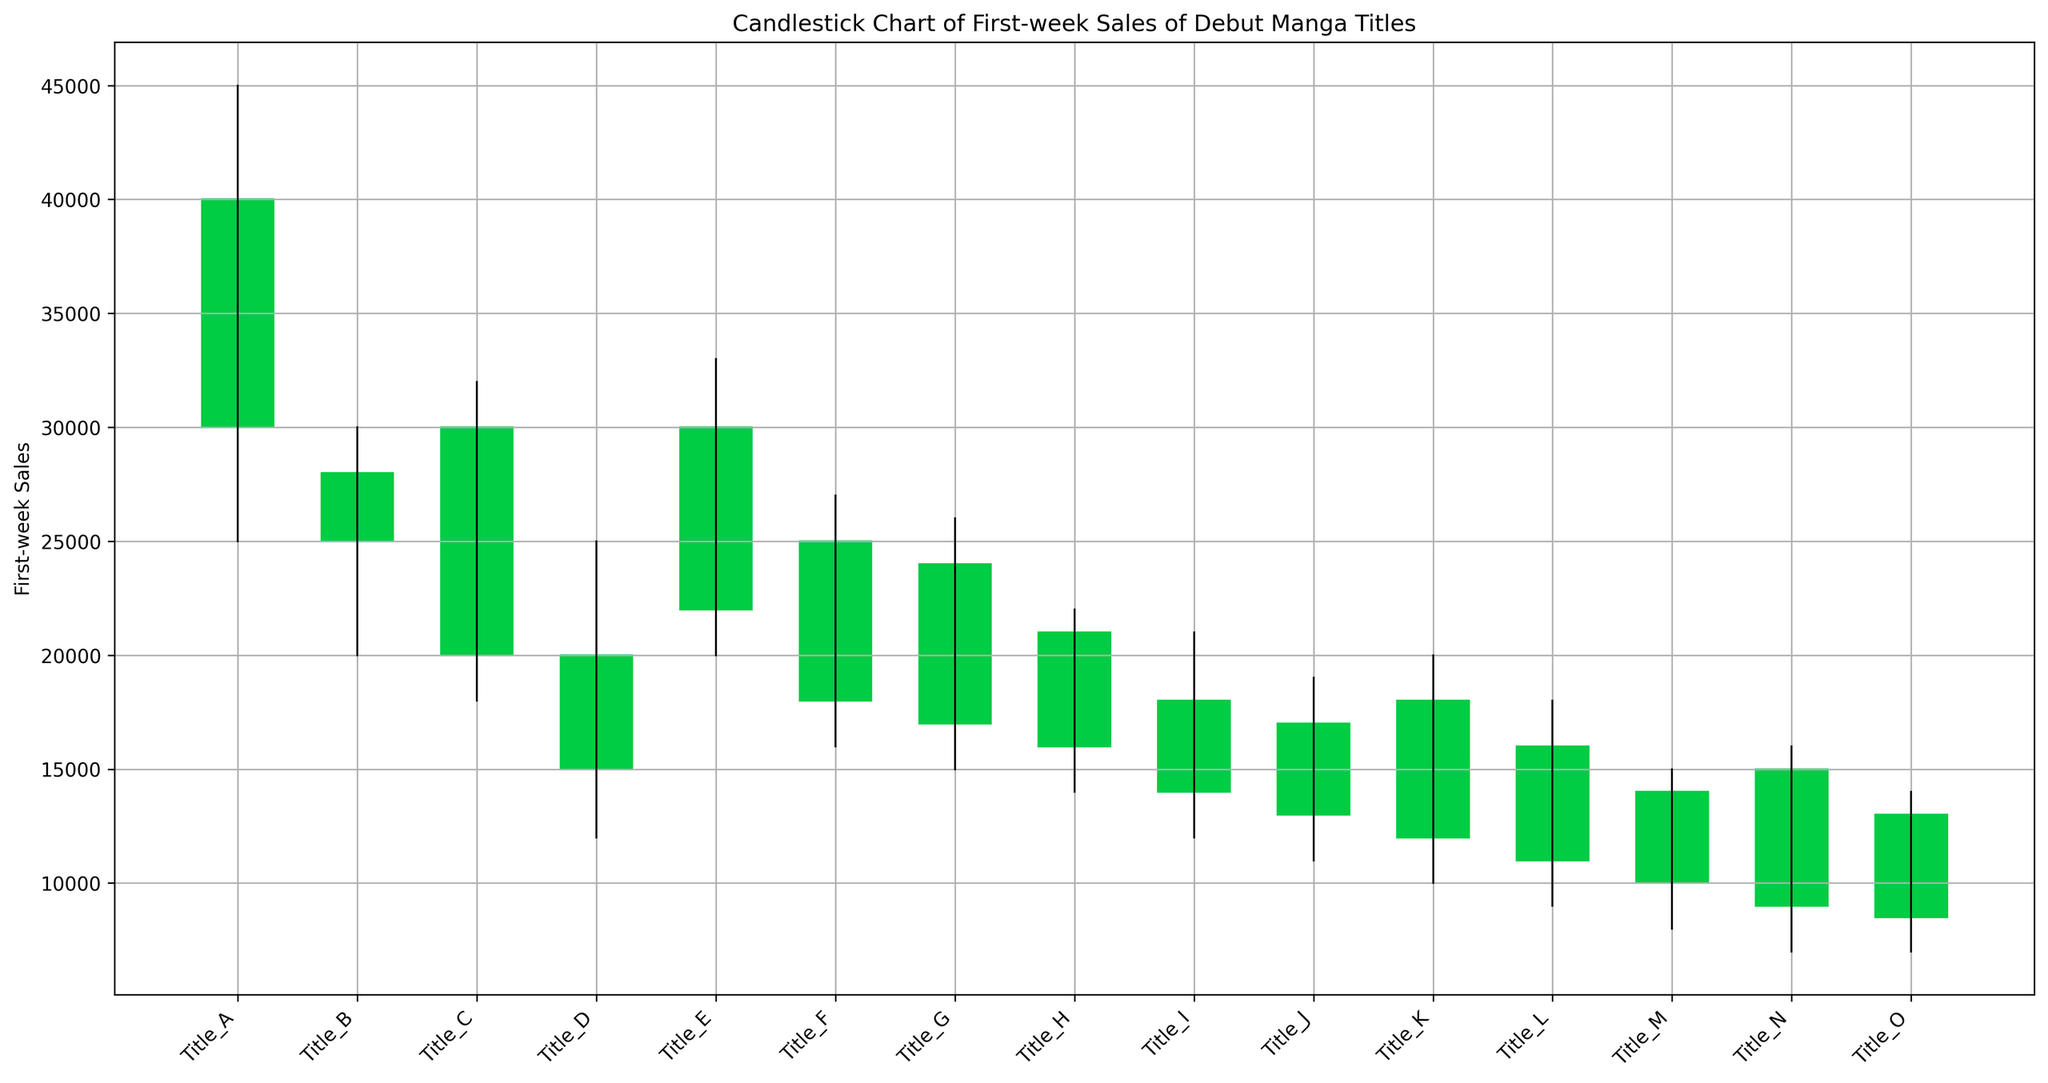Which title has the highest first-week sales? By observing the highest closing value among the candlesticks, we identify that "Title_A" from Shueisha has the highest first-week sales as its closing value is 40,000.
Answer: Title_A Which publisher's manga title has the smallest difference between its low and high sales? Calculating the difference between the high and low for each title, the smallest difference is for "Title_H" from Akita Shoten, with a difference of 8,000 (22,000 - 14,000).
Answer: Akita Shoten How many titles closed higher than they opened? Counting the titles where the closing value is greater than the opening value, we have "Title_A," "Title_C," "Title_E," "Title_F," "Title_G," "Title_H," "Title_K," and "Title_N." Thus, there are eight titles.
Answer: 8 Which titles experienced the largest drop from their high to their low price? The largest difference is calculated by finding the high-low difference for each title. "Title_M" from Ohta Publishing experienced the largest drop, with a difference of 7,000 (15,000 - 8,000).
Answer: Title_M Among the titles that closed lower than they opened, which one had the highest closing sales? Examining titles where the closing value is lower than the opening value, we compare their closing values. "Title_B" from Kodansha, which closed at 28,000, has the highest closing sales among them.
Answer: Title_B Which publisher's manga title showed the greatest increase from their opening to closing price? The greatest increase is found by calculating the difference between the closing and opening values for each title. "Title_K" from Mag Garden saw an increase of 6,000 (18,000 - 12,000).
Answer: Mag Garden What is the average low sales value of the manga titles? Adding up all the low values (25,000 + 20,000 + 18,000 + 12,000 + 20,000 + 16,000 + 15,000 + 14,000 + 12,000 + 11,000 + 10,000 + 9,000 + 8,000 + 7,000 + 7,000) gives 204,000. Dividing this by the number of titles (15) results in an average low value of 13,600.
Answer: 13,600 Which title had the greatest range (difference between high and low) in sales? The greatest range is identified by finding the difference between high and low for each title. "Title_A" from Shueisha has the greatest range with a difference of 20,000 (45,000 - 25,000).
Answer: Title_A How many titles had a high value that exceeded 30,000? Counting titles with a high value over 30,000, we include "Title_A," "Title_C," "Title_E," and "Title_B," resulting in four titles.
Answer: 4 